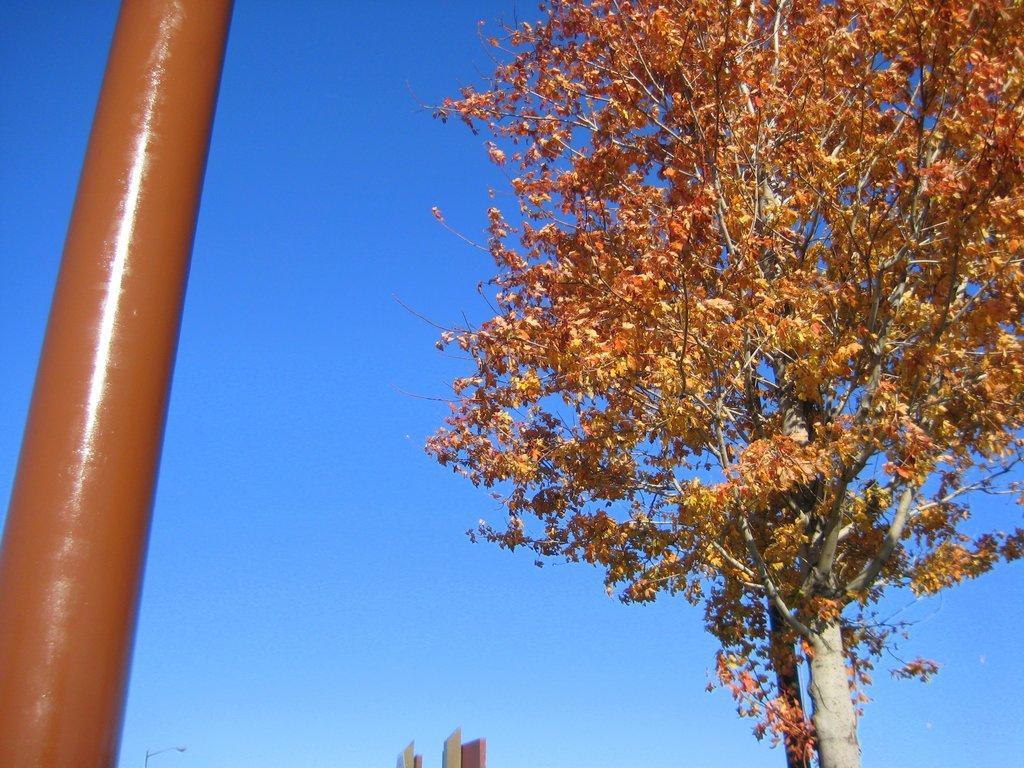In one or two sentences, can you explain what this image depicts? In this image I can see a pole, tree, buildings and the blue sky. This image is taken may be during a day. 